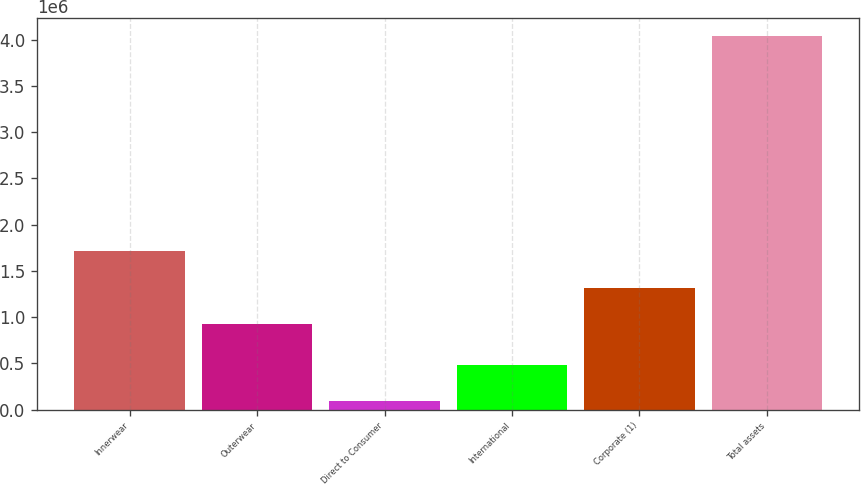Convert chart to OTSL. <chart><loc_0><loc_0><loc_500><loc_500><bar_chart><fcel>Innerwear<fcel>Outerwear<fcel>Direct to Consumer<fcel>International<fcel>Corporate (1)<fcel>Total assets<nl><fcel>1.70926e+06<fcel>919736<fcel>87069<fcel>481829<fcel>1.3145e+06<fcel>4.03467e+06<nl></chart> 